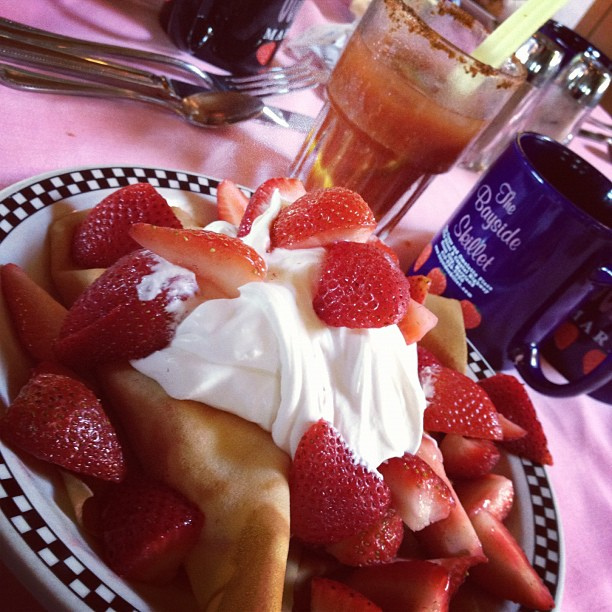Identify the text contained in this image. The Bayside Skillet 